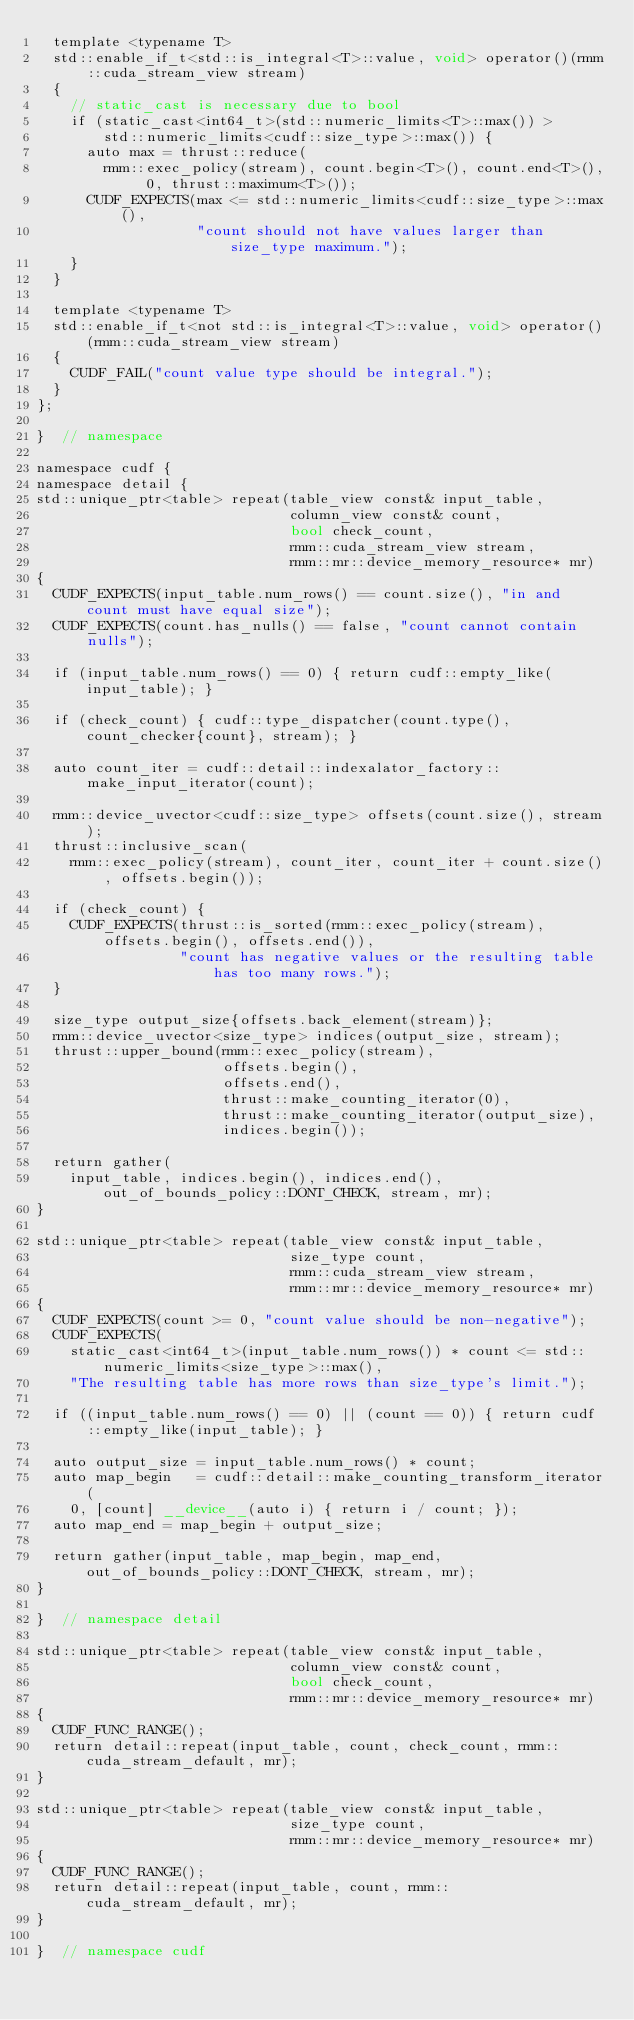Convert code to text. <code><loc_0><loc_0><loc_500><loc_500><_Cuda_>  template <typename T>
  std::enable_if_t<std::is_integral<T>::value, void> operator()(rmm::cuda_stream_view stream)
  {
    // static_cast is necessary due to bool
    if (static_cast<int64_t>(std::numeric_limits<T>::max()) >
        std::numeric_limits<cudf::size_type>::max()) {
      auto max = thrust::reduce(
        rmm::exec_policy(stream), count.begin<T>(), count.end<T>(), 0, thrust::maximum<T>());
      CUDF_EXPECTS(max <= std::numeric_limits<cudf::size_type>::max(),
                   "count should not have values larger than size_type maximum.");
    }
  }

  template <typename T>
  std::enable_if_t<not std::is_integral<T>::value, void> operator()(rmm::cuda_stream_view stream)
  {
    CUDF_FAIL("count value type should be integral.");
  }
};

}  // namespace

namespace cudf {
namespace detail {
std::unique_ptr<table> repeat(table_view const& input_table,
                              column_view const& count,
                              bool check_count,
                              rmm::cuda_stream_view stream,
                              rmm::mr::device_memory_resource* mr)
{
  CUDF_EXPECTS(input_table.num_rows() == count.size(), "in and count must have equal size");
  CUDF_EXPECTS(count.has_nulls() == false, "count cannot contain nulls");

  if (input_table.num_rows() == 0) { return cudf::empty_like(input_table); }

  if (check_count) { cudf::type_dispatcher(count.type(), count_checker{count}, stream); }

  auto count_iter = cudf::detail::indexalator_factory::make_input_iterator(count);

  rmm::device_uvector<cudf::size_type> offsets(count.size(), stream);
  thrust::inclusive_scan(
    rmm::exec_policy(stream), count_iter, count_iter + count.size(), offsets.begin());

  if (check_count) {
    CUDF_EXPECTS(thrust::is_sorted(rmm::exec_policy(stream), offsets.begin(), offsets.end()),
                 "count has negative values or the resulting table has too many rows.");
  }

  size_type output_size{offsets.back_element(stream)};
  rmm::device_uvector<size_type> indices(output_size, stream);
  thrust::upper_bound(rmm::exec_policy(stream),
                      offsets.begin(),
                      offsets.end(),
                      thrust::make_counting_iterator(0),
                      thrust::make_counting_iterator(output_size),
                      indices.begin());

  return gather(
    input_table, indices.begin(), indices.end(), out_of_bounds_policy::DONT_CHECK, stream, mr);
}

std::unique_ptr<table> repeat(table_view const& input_table,
                              size_type count,
                              rmm::cuda_stream_view stream,
                              rmm::mr::device_memory_resource* mr)
{
  CUDF_EXPECTS(count >= 0, "count value should be non-negative");
  CUDF_EXPECTS(
    static_cast<int64_t>(input_table.num_rows()) * count <= std::numeric_limits<size_type>::max(),
    "The resulting table has more rows than size_type's limit.");

  if ((input_table.num_rows() == 0) || (count == 0)) { return cudf::empty_like(input_table); }

  auto output_size = input_table.num_rows() * count;
  auto map_begin   = cudf::detail::make_counting_transform_iterator(
    0, [count] __device__(auto i) { return i / count; });
  auto map_end = map_begin + output_size;

  return gather(input_table, map_begin, map_end, out_of_bounds_policy::DONT_CHECK, stream, mr);
}

}  // namespace detail

std::unique_ptr<table> repeat(table_view const& input_table,
                              column_view const& count,
                              bool check_count,
                              rmm::mr::device_memory_resource* mr)
{
  CUDF_FUNC_RANGE();
  return detail::repeat(input_table, count, check_count, rmm::cuda_stream_default, mr);
}

std::unique_ptr<table> repeat(table_view const& input_table,
                              size_type count,
                              rmm::mr::device_memory_resource* mr)
{
  CUDF_FUNC_RANGE();
  return detail::repeat(input_table, count, rmm::cuda_stream_default, mr);
}

}  // namespace cudf
</code> 